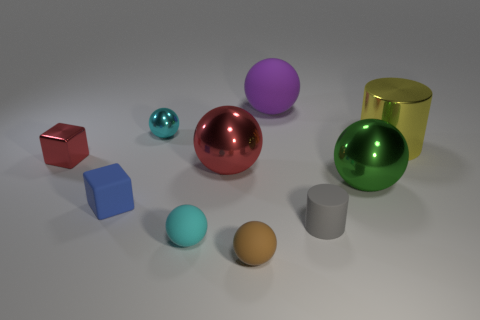There is another tiny metallic object that is the same shape as the green shiny object; what color is it? The tiny metallic object that shares its shape with the larger green sphere is cyan, characterized by a vivid light blue-green hue reminiscent of the color of tropical waters. 